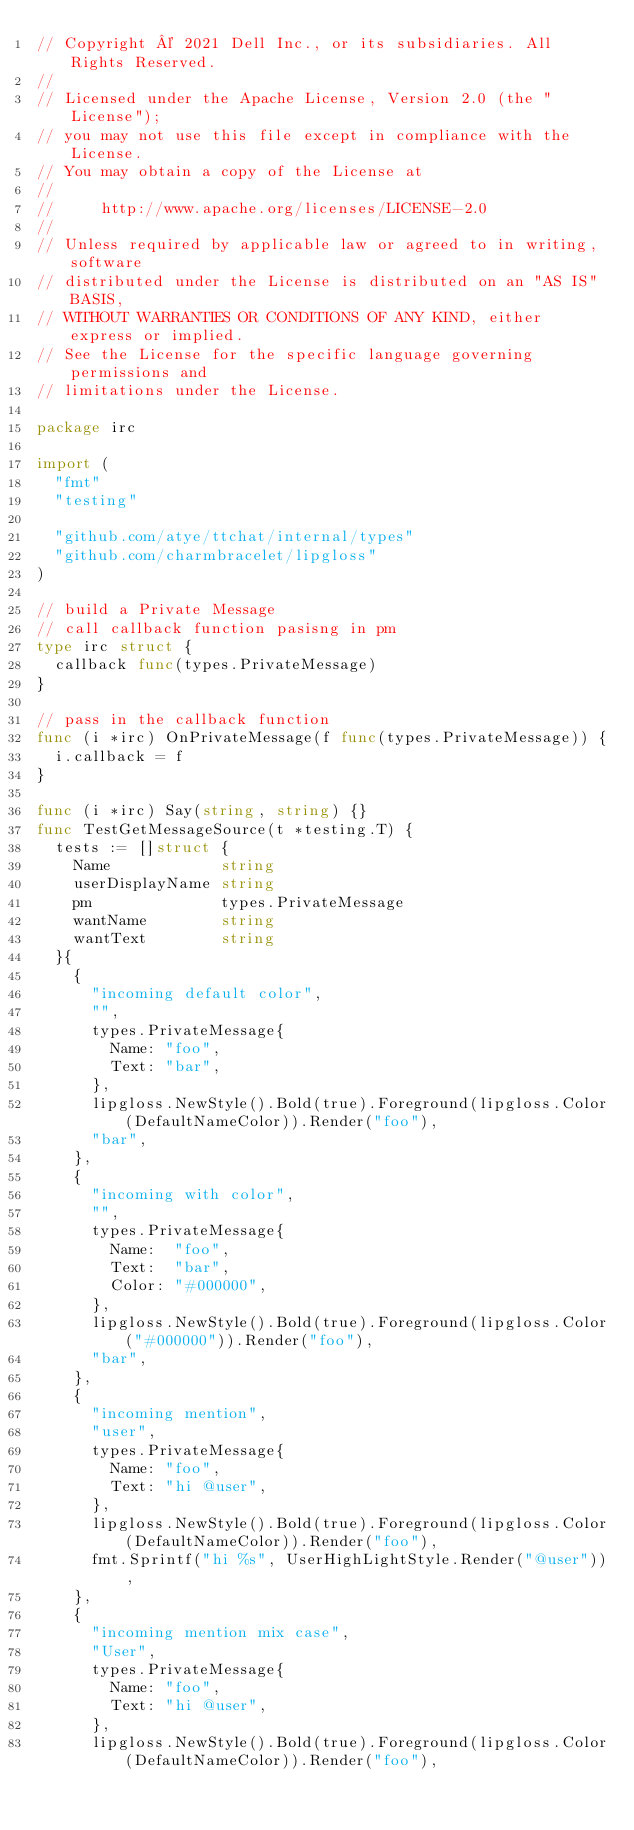Convert code to text. <code><loc_0><loc_0><loc_500><loc_500><_Go_>// Copyright © 2021 Dell Inc., or its subsidiaries. All Rights Reserved.
//
// Licensed under the Apache License, Version 2.0 (the "License");
// you may not use this file except in compliance with the License.
// You may obtain a copy of the License at
//
//     http://www.apache.org/licenses/LICENSE-2.0
//
// Unless required by applicable law or agreed to in writing, software
// distributed under the License is distributed on an "AS IS" BASIS,
// WITHOUT WARRANTIES OR CONDITIONS OF ANY KIND, either express or implied.
// See the License for the specific language governing permissions and
// limitations under the License.

package irc

import (
	"fmt"
	"testing"

	"github.com/atye/ttchat/internal/types"
	"github.com/charmbracelet/lipgloss"
)

// build a Private Message
// call callback function pasisng in pm
type irc struct {
	callback func(types.PrivateMessage)
}

// pass in the callback function
func (i *irc) OnPrivateMessage(f func(types.PrivateMessage)) {
	i.callback = f
}

func (i *irc) Say(string, string) {}
func TestGetMessageSource(t *testing.T) {
	tests := []struct {
		Name            string
		userDisplayName string
		pm              types.PrivateMessage
		wantName        string
		wantText        string
	}{
		{
			"incoming default color",
			"",
			types.PrivateMessage{
				Name: "foo",
				Text: "bar",
			},
			lipgloss.NewStyle().Bold(true).Foreground(lipgloss.Color(DefaultNameColor)).Render("foo"),
			"bar",
		},
		{
			"incoming with color",
			"",
			types.PrivateMessage{
				Name:  "foo",
				Text:  "bar",
				Color: "#000000",
			},
			lipgloss.NewStyle().Bold(true).Foreground(lipgloss.Color("#000000")).Render("foo"),
			"bar",
		},
		{
			"incoming mention",
			"user",
			types.PrivateMessage{
				Name: "foo",
				Text: "hi @user",
			},
			lipgloss.NewStyle().Bold(true).Foreground(lipgloss.Color(DefaultNameColor)).Render("foo"),
			fmt.Sprintf("hi %s", UserHighLightStyle.Render("@user")),
		},
		{
			"incoming mention mix case",
			"User",
			types.PrivateMessage{
				Name: "foo",
				Text: "hi @user",
			},
			lipgloss.NewStyle().Bold(true).Foreground(lipgloss.Color(DefaultNameColor)).Render("foo"),</code> 